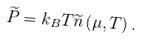<formula> <loc_0><loc_0><loc_500><loc_500>\widetilde { P } = k _ { B } T \widetilde { n } \left ( \mu , T \right ) .</formula> 